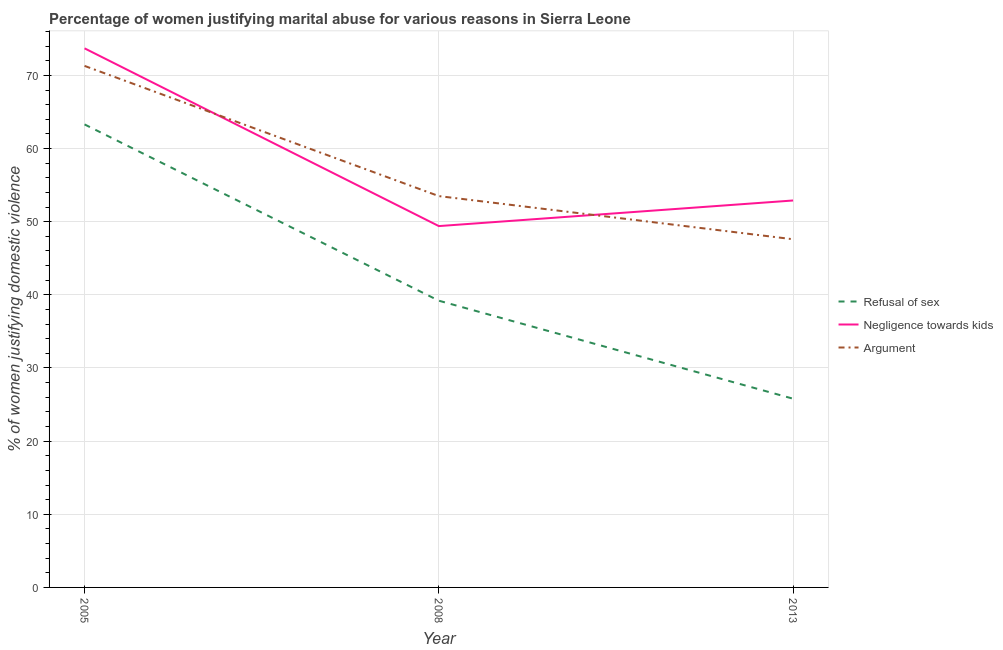How many different coloured lines are there?
Ensure brevity in your answer.  3. Does the line corresponding to percentage of women justifying domestic violence due to negligence towards kids intersect with the line corresponding to percentage of women justifying domestic violence due to refusal of sex?
Keep it short and to the point. No. What is the percentage of women justifying domestic violence due to negligence towards kids in 2013?
Give a very brief answer. 52.9. Across all years, what is the maximum percentage of women justifying domestic violence due to arguments?
Make the answer very short. 71.3. Across all years, what is the minimum percentage of women justifying domestic violence due to arguments?
Your answer should be very brief. 47.6. In which year was the percentage of women justifying domestic violence due to arguments maximum?
Your response must be concise. 2005. What is the total percentage of women justifying domestic violence due to arguments in the graph?
Give a very brief answer. 172.4. What is the difference between the percentage of women justifying domestic violence due to arguments in 2008 and that in 2013?
Your answer should be compact. 5.9. What is the difference between the percentage of women justifying domestic violence due to refusal of sex in 2008 and the percentage of women justifying domestic violence due to negligence towards kids in 2005?
Provide a short and direct response. -34.5. What is the average percentage of women justifying domestic violence due to negligence towards kids per year?
Keep it short and to the point. 58.67. In the year 2008, what is the difference between the percentage of women justifying domestic violence due to arguments and percentage of women justifying domestic violence due to refusal of sex?
Ensure brevity in your answer.  14.3. In how many years, is the percentage of women justifying domestic violence due to arguments greater than 2 %?
Make the answer very short. 3. What is the ratio of the percentage of women justifying domestic violence due to negligence towards kids in 2005 to that in 2008?
Make the answer very short. 1.49. What is the difference between the highest and the second highest percentage of women justifying domestic violence due to refusal of sex?
Provide a short and direct response. 24.1. What is the difference between the highest and the lowest percentage of women justifying domestic violence due to refusal of sex?
Give a very brief answer. 37.5. In how many years, is the percentage of women justifying domestic violence due to arguments greater than the average percentage of women justifying domestic violence due to arguments taken over all years?
Provide a short and direct response. 1. Does the percentage of women justifying domestic violence due to negligence towards kids monotonically increase over the years?
Make the answer very short. No. Is the percentage of women justifying domestic violence due to arguments strictly less than the percentage of women justifying domestic violence due to negligence towards kids over the years?
Make the answer very short. No. How many lines are there?
Your answer should be very brief. 3. What is the difference between two consecutive major ticks on the Y-axis?
Your answer should be compact. 10. Are the values on the major ticks of Y-axis written in scientific E-notation?
Your answer should be very brief. No. Where does the legend appear in the graph?
Offer a very short reply. Center right. How are the legend labels stacked?
Your answer should be very brief. Vertical. What is the title of the graph?
Your answer should be compact. Percentage of women justifying marital abuse for various reasons in Sierra Leone. Does "Textiles and clothing" appear as one of the legend labels in the graph?
Your answer should be compact. No. What is the label or title of the Y-axis?
Provide a short and direct response. % of women justifying domestic violence. What is the % of women justifying domestic violence in Refusal of sex in 2005?
Ensure brevity in your answer.  63.3. What is the % of women justifying domestic violence in Negligence towards kids in 2005?
Your response must be concise. 73.7. What is the % of women justifying domestic violence in Argument in 2005?
Offer a terse response. 71.3. What is the % of women justifying domestic violence in Refusal of sex in 2008?
Your response must be concise. 39.2. What is the % of women justifying domestic violence in Negligence towards kids in 2008?
Give a very brief answer. 49.4. What is the % of women justifying domestic violence of Argument in 2008?
Your answer should be compact. 53.5. What is the % of women justifying domestic violence in Refusal of sex in 2013?
Make the answer very short. 25.8. What is the % of women justifying domestic violence of Negligence towards kids in 2013?
Give a very brief answer. 52.9. What is the % of women justifying domestic violence in Argument in 2013?
Give a very brief answer. 47.6. Across all years, what is the maximum % of women justifying domestic violence in Refusal of sex?
Offer a terse response. 63.3. Across all years, what is the maximum % of women justifying domestic violence of Negligence towards kids?
Your answer should be very brief. 73.7. Across all years, what is the maximum % of women justifying domestic violence in Argument?
Keep it short and to the point. 71.3. Across all years, what is the minimum % of women justifying domestic violence of Refusal of sex?
Your answer should be very brief. 25.8. Across all years, what is the minimum % of women justifying domestic violence of Negligence towards kids?
Provide a succinct answer. 49.4. Across all years, what is the minimum % of women justifying domestic violence in Argument?
Keep it short and to the point. 47.6. What is the total % of women justifying domestic violence in Refusal of sex in the graph?
Give a very brief answer. 128.3. What is the total % of women justifying domestic violence in Negligence towards kids in the graph?
Ensure brevity in your answer.  176. What is the total % of women justifying domestic violence in Argument in the graph?
Offer a very short reply. 172.4. What is the difference between the % of women justifying domestic violence in Refusal of sex in 2005 and that in 2008?
Make the answer very short. 24.1. What is the difference between the % of women justifying domestic violence in Negligence towards kids in 2005 and that in 2008?
Keep it short and to the point. 24.3. What is the difference between the % of women justifying domestic violence of Argument in 2005 and that in 2008?
Your response must be concise. 17.8. What is the difference between the % of women justifying domestic violence of Refusal of sex in 2005 and that in 2013?
Give a very brief answer. 37.5. What is the difference between the % of women justifying domestic violence in Negligence towards kids in 2005 and that in 2013?
Offer a terse response. 20.8. What is the difference between the % of women justifying domestic violence of Argument in 2005 and that in 2013?
Keep it short and to the point. 23.7. What is the difference between the % of women justifying domestic violence of Refusal of sex in 2008 and that in 2013?
Your response must be concise. 13.4. What is the difference between the % of women justifying domestic violence of Argument in 2008 and that in 2013?
Your answer should be very brief. 5.9. What is the difference between the % of women justifying domestic violence of Refusal of sex in 2005 and the % of women justifying domestic violence of Argument in 2008?
Provide a succinct answer. 9.8. What is the difference between the % of women justifying domestic violence of Negligence towards kids in 2005 and the % of women justifying domestic violence of Argument in 2008?
Offer a very short reply. 20.2. What is the difference between the % of women justifying domestic violence in Refusal of sex in 2005 and the % of women justifying domestic violence in Argument in 2013?
Your response must be concise. 15.7. What is the difference between the % of women justifying domestic violence in Negligence towards kids in 2005 and the % of women justifying domestic violence in Argument in 2013?
Give a very brief answer. 26.1. What is the difference between the % of women justifying domestic violence of Refusal of sex in 2008 and the % of women justifying domestic violence of Negligence towards kids in 2013?
Your response must be concise. -13.7. What is the difference between the % of women justifying domestic violence of Negligence towards kids in 2008 and the % of women justifying domestic violence of Argument in 2013?
Make the answer very short. 1.8. What is the average % of women justifying domestic violence in Refusal of sex per year?
Give a very brief answer. 42.77. What is the average % of women justifying domestic violence of Negligence towards kids per year?
Ensure brevity in your answer.  58.67. What is the average % of women justifying domestic violence in Argument per year?
Give a very brief answer. 57.47. In the year 2005, what is the difference between the % of women justifying domestic violence in Refusal of sex and % of women justifying domestic violence in Argument?
Offer a very short reply. -8. In the year 2008, what is the difference between the % of women justifying domestic violence in Refusal of sex and % of women justifying domestic violence in Argument?
Give a very brief answer. -14.3. In the year 2013, what is the difference between the % of women justifying domestic violence of Refusal of sex and % of women justifying domestic violence of Negligence towards kids?
Provide a short and direct response. -27.1. In the year 2013, what is the difference between the % of women justifying domestic violence in Refusal of sex and % of women justifying domestic violence in Argument?
Provide a short and direct response. -21.8. In the year 2013, what is the difference between the % of women justifying domestic violence in Negligence towards kids and % of women justifying domestic violence in Argument?
Provide a succinct answer. 5.3. What is the ratio of the % of women justifying domestic violence of Refusal of sex in 2005 to that in 2008?
Make the answer very short. 1.61. What is the ratio of the % of women justifying domestic violence of Negligence towards kids in 2005 to that in 2008?
Keep it short and to the point. 1.49. What is the ratio of the % of women justifying domestic violence in Argument in 2005 to that in 2008?
Ensure brevity in your answer.  1.33. What is the ratio of the % of women justifying domestic violence in Refusal of sex in 2005 to that in 2013?
Ensure brevity in your answer.  2.45. What is the ratio of the % of women justifying domestic violence of Negligence towards kids in 2005 to that in 2013?
Provide a short and direct response. 1.39. What is the ratio of the % of women justifying domestic violence of Argument in 2005 to that in 2013?
Provide a succinct answer. 1.5. What is the ratio of the % of women justifying domestic violence of Refusal of sex in 2008 to that in 2013?
Give a very brief answer. 1.52. What is the ratio of the % of women justifying domestic violence of Negligence towards kids in 2008 to that in 2013?
Provide a short and direct response. 0.93. What is the ratio of the % of women justifying domestic violence of Argument in 2008 to that in 2013?
Your answer should be compact. 1.12. What is the difference between the highest and the second highest % of women justifying domestic violence of Refusal of sex?
Your answer should be compact. 24.1. What is the difference between the highest and the second highest % of women justifying domestic violence in Negligence towards kids?
Ensure brevity in your answer.  20.8. What is the difference between the highest and the second highest % of women justifying domestic violence in Argument?
Your answer should be very brief. 17.8. What is the difference between the highest and the lowest % of women justifying domestic violence of Refusal of sex?
Offer a very short reply. 37.5. What is the difference between the highest and the lowest % of women justifying domestic violence of Negligence towards kids?
Your response must be concise. 24.3. What is the difference between the highest and the lowest % of women justifying domestic violence in Argument?
Offer a terse response. 23.7. 